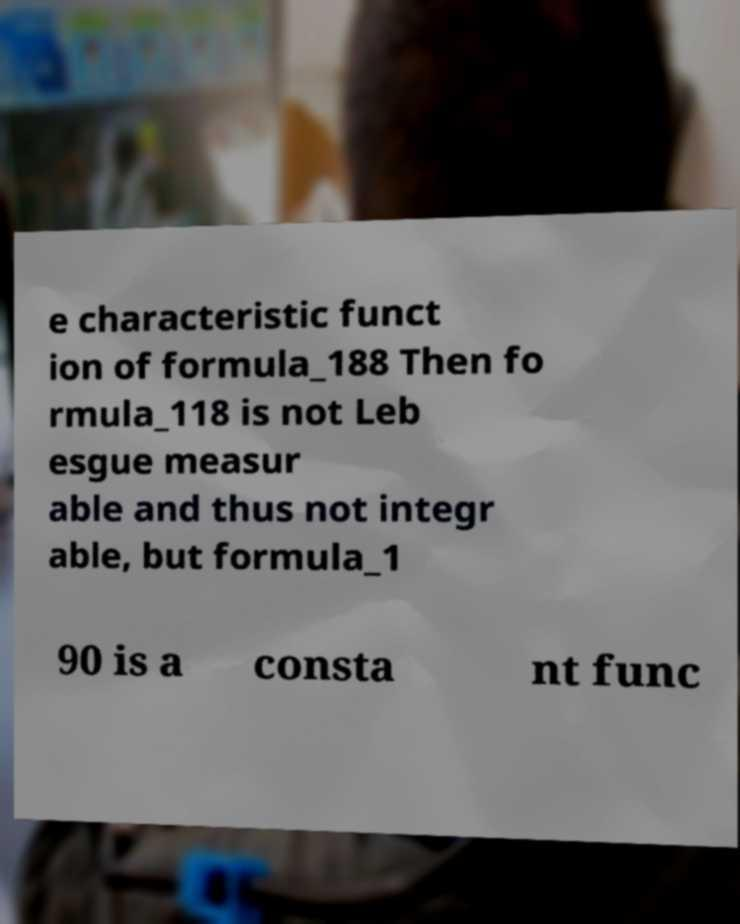What messages or text are displayed in this image? I need them in a readable, typed format. e characteristic funct ion of formula_188 Then fo rmula_118 is not Leb esgue measur able and thus not integr able, but formula_1 90 is a consta nt func 